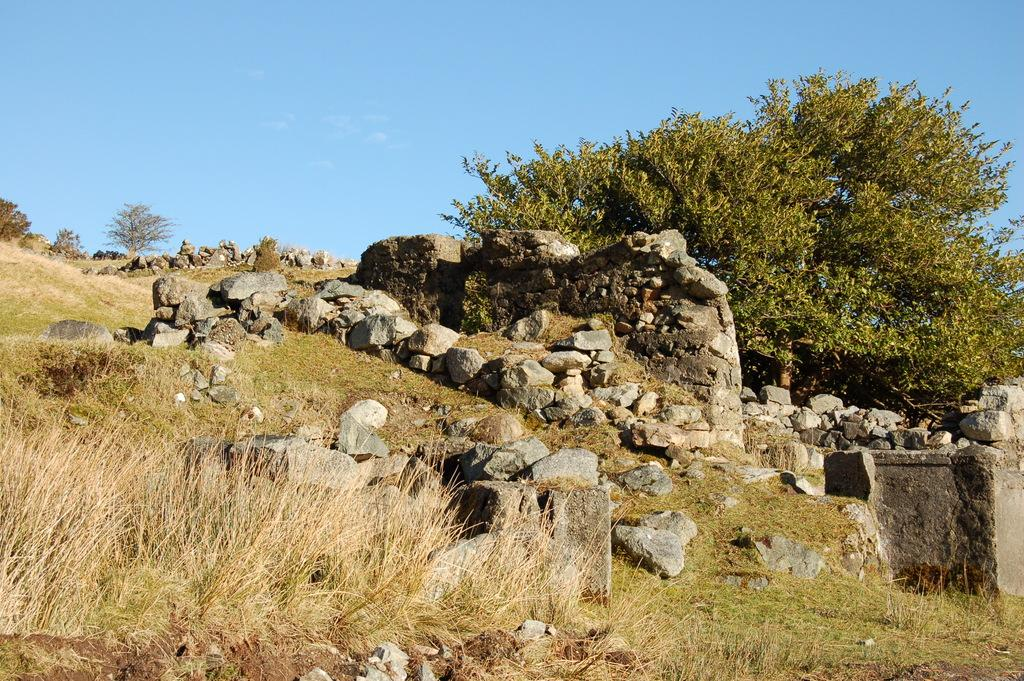What can be found in the middle of the image? There are stones and plants in the middle of the image. What is located on the right side of the image? There is a wall on the right side of the image. What type of vegetation is present at the back of the image? There are trees at the back of the image. What is visible at the top of the image? The sky is visible at the top of the image. What type of crime is being committed in the image? There is no indication of any crime being committed in the image. Can you see a stick in the image? There is no stick present in the image. 